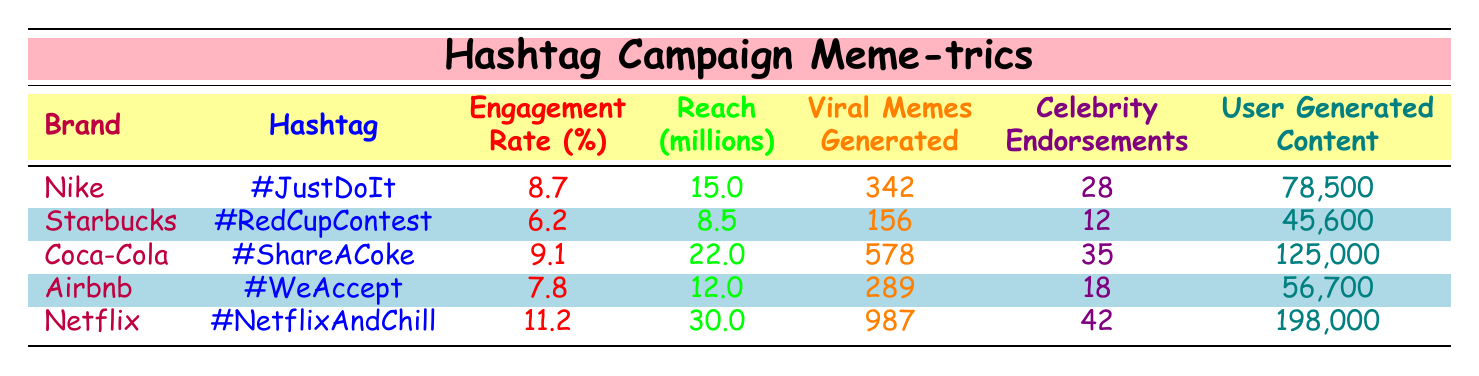What is the engagement rate for Netflix's hashtag campaign? The engagement rate for the Netflix campaign "#NetflixAndChill" is located in the engagement rate column in the row corresponding to Netflix, where it shows as 11.2%.
Answer: 11.2 Which brand generated the most viral memes? In the table, among all the brands listed, Netflix generated 987 viral memes, which is the highest number when compared to others.
Answer: Netflix Did Starbucks have more celebrity endorsements than Airbnb? The table shows Starbucks with 12 celebrity endorsements while Airbnb has 18. Therefore, it is false that Starbucks had more endorsements.
Answer: No What is the total reach of both Nike and Coca-Cola campaigns combined? To find the total reach, we look at the reach values for Nike (15 million) and Coca-Cola (22 million) and sum them: 15 + 22 = 37 million.
Answer: 37 million Which brand had the longest campaign duration? The table indicates that Netflix's campaign lasted 90 days, which is longer than the campaigns of any other listed brands.
Answer: Netflix What is the average engagement rate of the brands listed? The engagement rates are 8.7, 6.2, 9.1, 7.8, and 11.2. To calculate the average, sum these values (8.7 + 6.2 + 9.1 + 7.8 + 11.2 = 43) and divide by 5 (43/5 = 8.6).
Answer: 8.6 Is the user-generated content for Coca-Cola higher than that for Nike? By comparing the user-generated content amounts, Coca-Cola has 125,000 while Nike has 78,500, which means Coca-Cola definitely has more user-generated content.
Answer: Yes What is the difference in viral memes generated between Coca-Cola and Starbucks? Coca-Cola generated 578 viral memes and Starbucks generated 156. The difference is calculated by subtracting: 578 - 156 = 422.
Answer: 422 